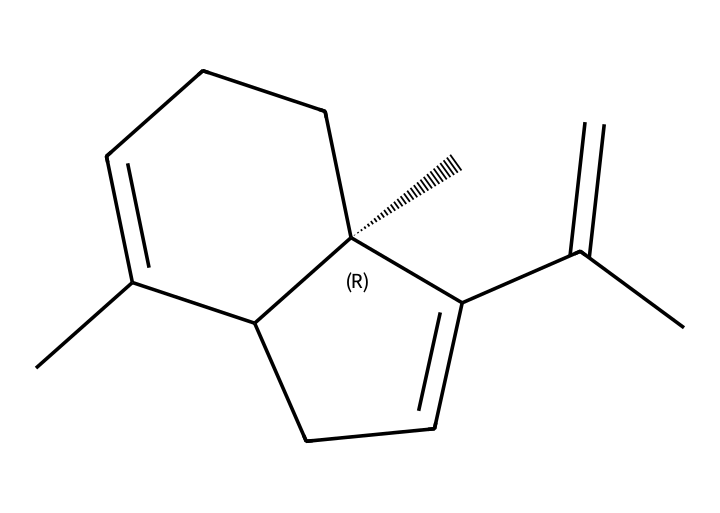What is the molecular formula of beta-caryophyllene? By analyzing the SMILES representation, we identify the carbon (C) and hydrogen (H) atoms. The structure has 15 carbon atoms and 24 hydrogen atoms, leading to the molecular formula C15H24.
Answer: C15H24 How many chiral centers are present in beta-caryophyllene? Examining the SMILES, we can identify that there is one chiral center denoted by the symbol "@". This indicates the presence of one chiral carbon in the structure.
Answer: 1 What type of chemical compound is beta-caryophyllene? The compound represented in the SMILES is classified as a terpene due to its structure involving multiple isoprene units, specifically a bicyclic structure that is characteristic of this class of compounds.
Answer: terpene What is the significance of the double bonds in beta-caryophyllene? The double bonds in the structure contribute to the compound's reactivity and influence its potential biological properties, including its anti-inflammatory effects critical for muscle recovery.
Answer: reactivity Can beta-caryophyllene interact with cannabinoid receptors? The structure of beta-caryophyllene, particularly its unique composition and properties as a terpene, allows it to interact with cannabinoid receptors, which is linked to its potential health benefits.
Answer: yes What is the potential health benefit of beta-caryophyllene for athletes? Beta-caryophyllene has shown potential anti-inflammatory properties that can aid in muscle recovery, making it beneficial for athletes in reducing soreness and enhancing performance after intense physical activity.
Answer: anti-inflammatory 